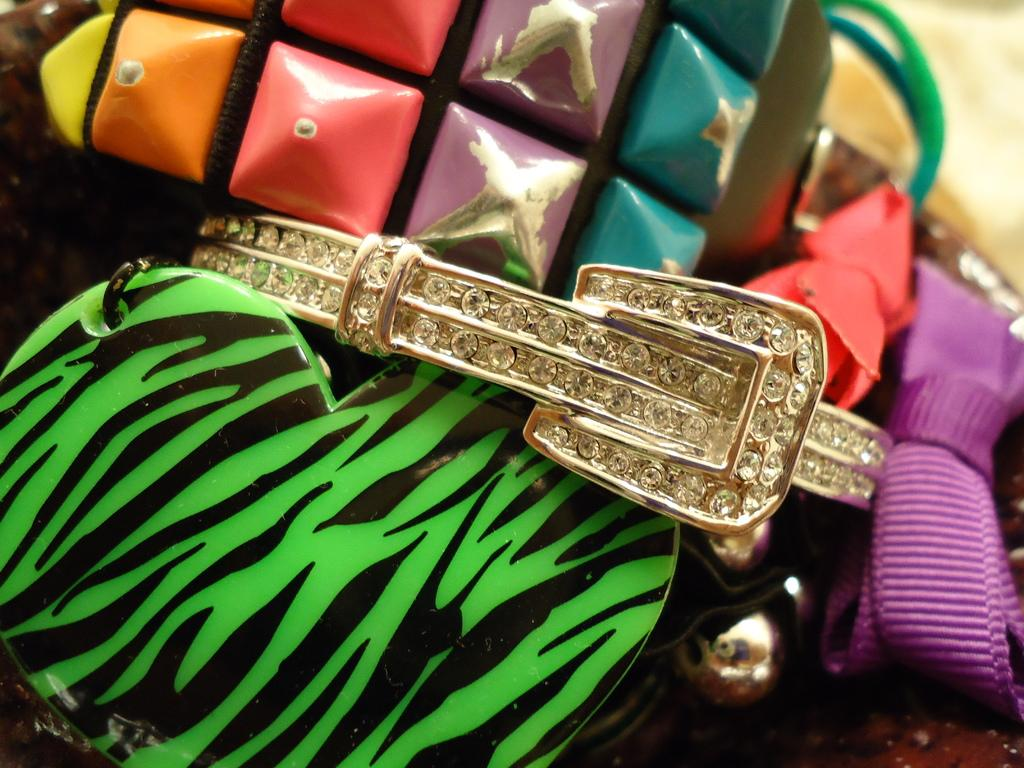What is the main object in the image that contains stones? There is an object with stones in the image. What other items can be seen in the image besides the object with stones? There are other items in the image. Can you describe the lace in the image? There is a lace on the right side of the image. What type of quill is being used to write on the lace in the image? There is no quill or writing activity present in the image. What angle is the light source coming from in the image? The facts provided do not mention any light source or angle, so it cannot be determined from the image. 